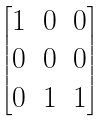<formula> <loc_0><loc_0><loc_500><loc_500>\begin{bmatrix} 1 & 0 & 0 \\ 0 & 0 & 0 \\ 0 & 1 & 1 \end{bmatrix}</formula> 